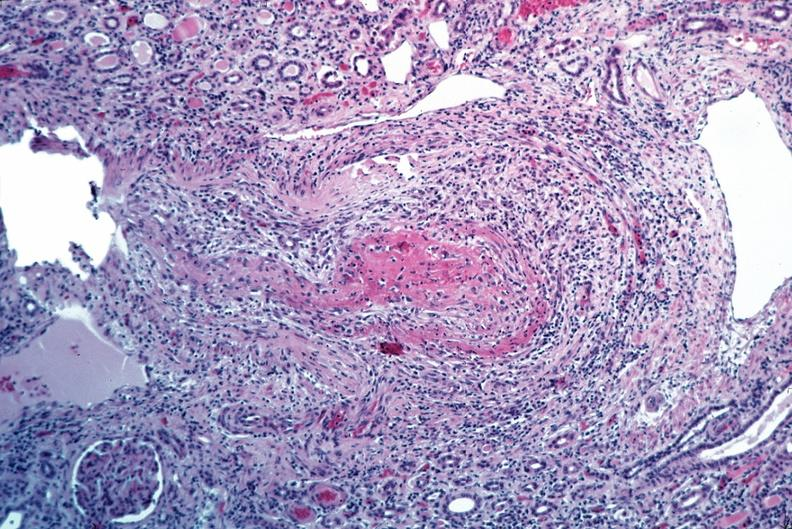s siamese twins present?
Answer the question using a single word or phrase. No 